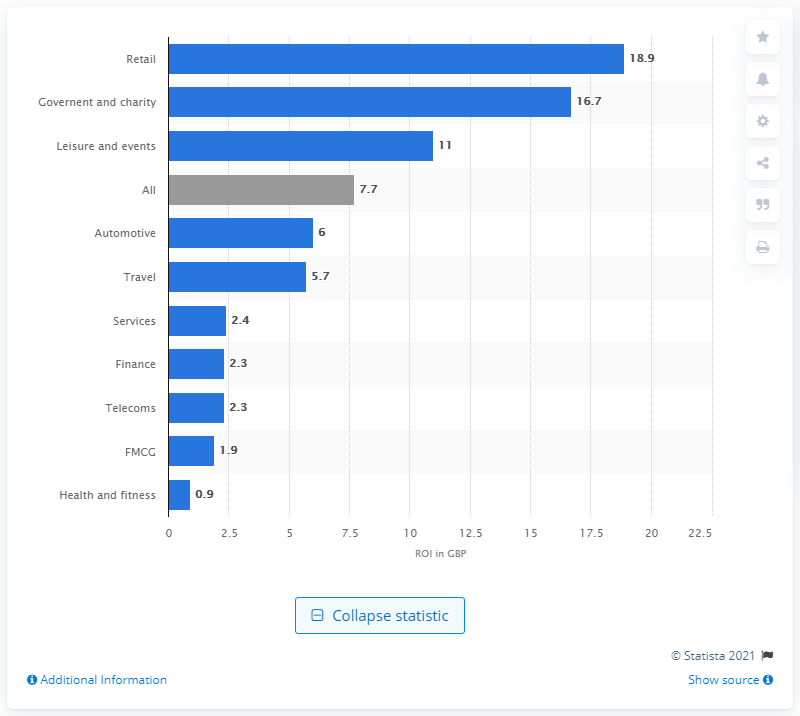List a handful of essential elements in this visual. In 2013, the retail sector had the highest return on investment (ROI). 